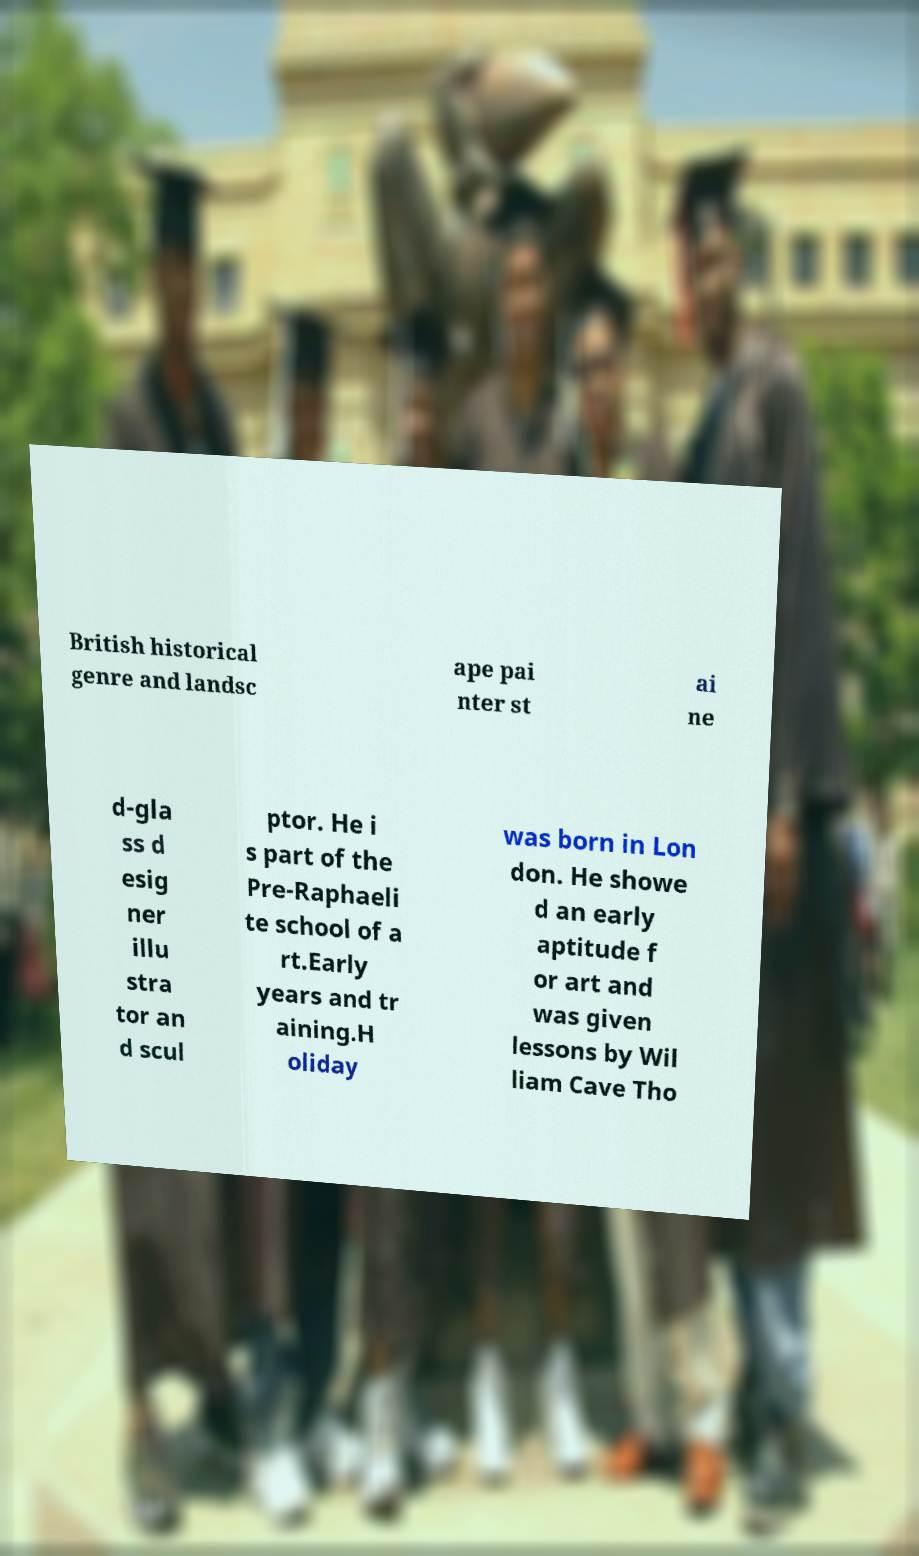Could you extract and type out the text from this image? British historical genre and landsc ape pai nter st ai ne d-gla ss d esig ner illu stra tor an d scul ptor. He i s part of the Pre-Raphaeli te school of a rt.Early years and tr aining.H oliday was born in Lon don. He showe d an early aptitude f or art and was given lessons by Wil liam Cave Tho 